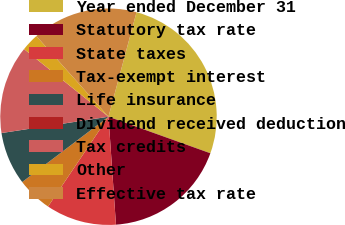Convert chart. <chart><loc_0><loc_0><loc_500><loc_500><pie_chart><fcel>Year ended December 31<fcel>Statutory tax rate<fcel>State taxes<fcel>Tax-exempt interest<fcel>Life insurance<fcel>Dividend received deduction<fcel>Tax credits<fcel>Other<fcel>Effective tax rate<nl><fcel>26.31%<fcel>18.42%<fcel>10.53%<fcel>5.26%<fcel>7.9%<fcel>0.0%<fcel>13.16%<fcel>2.63%<fcel>15.79%<nl></chart> 